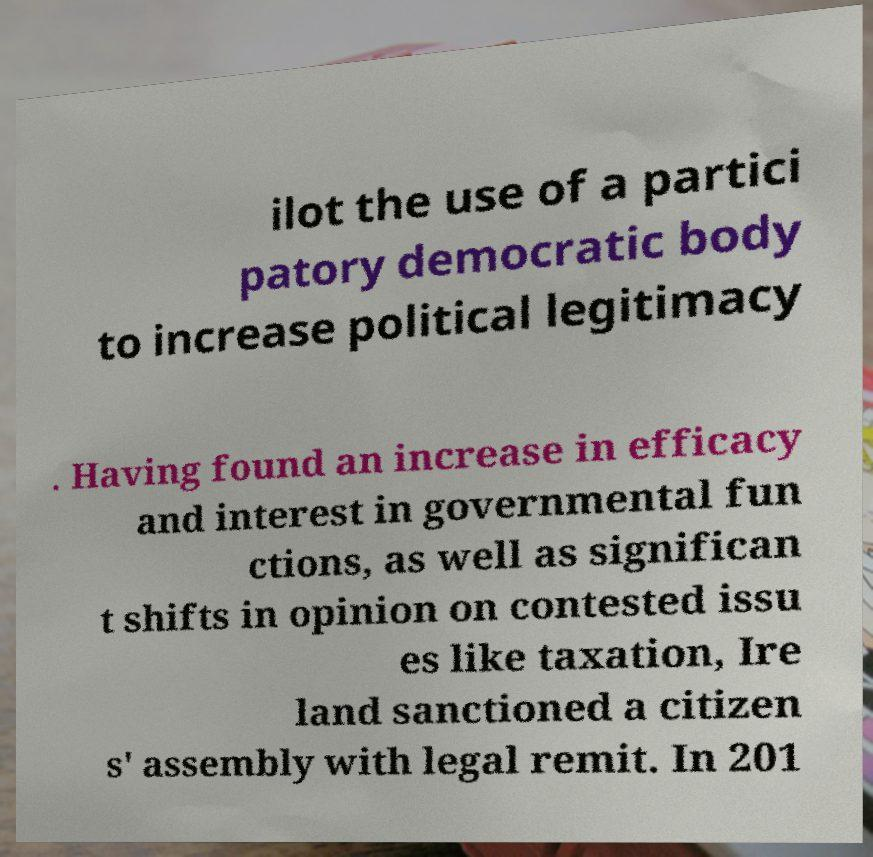Can you accurately transcribe the text from the provided image for me? ilot the use of a partici patory democratic body to increase political legitimacy . Having found an increase in efficacy and interest in governmental fun ctions, as well as significan t shifts in opinion on contested issu es like taxation, Ire land sanctioned a citizen s' assembly with legal remit. In 201 